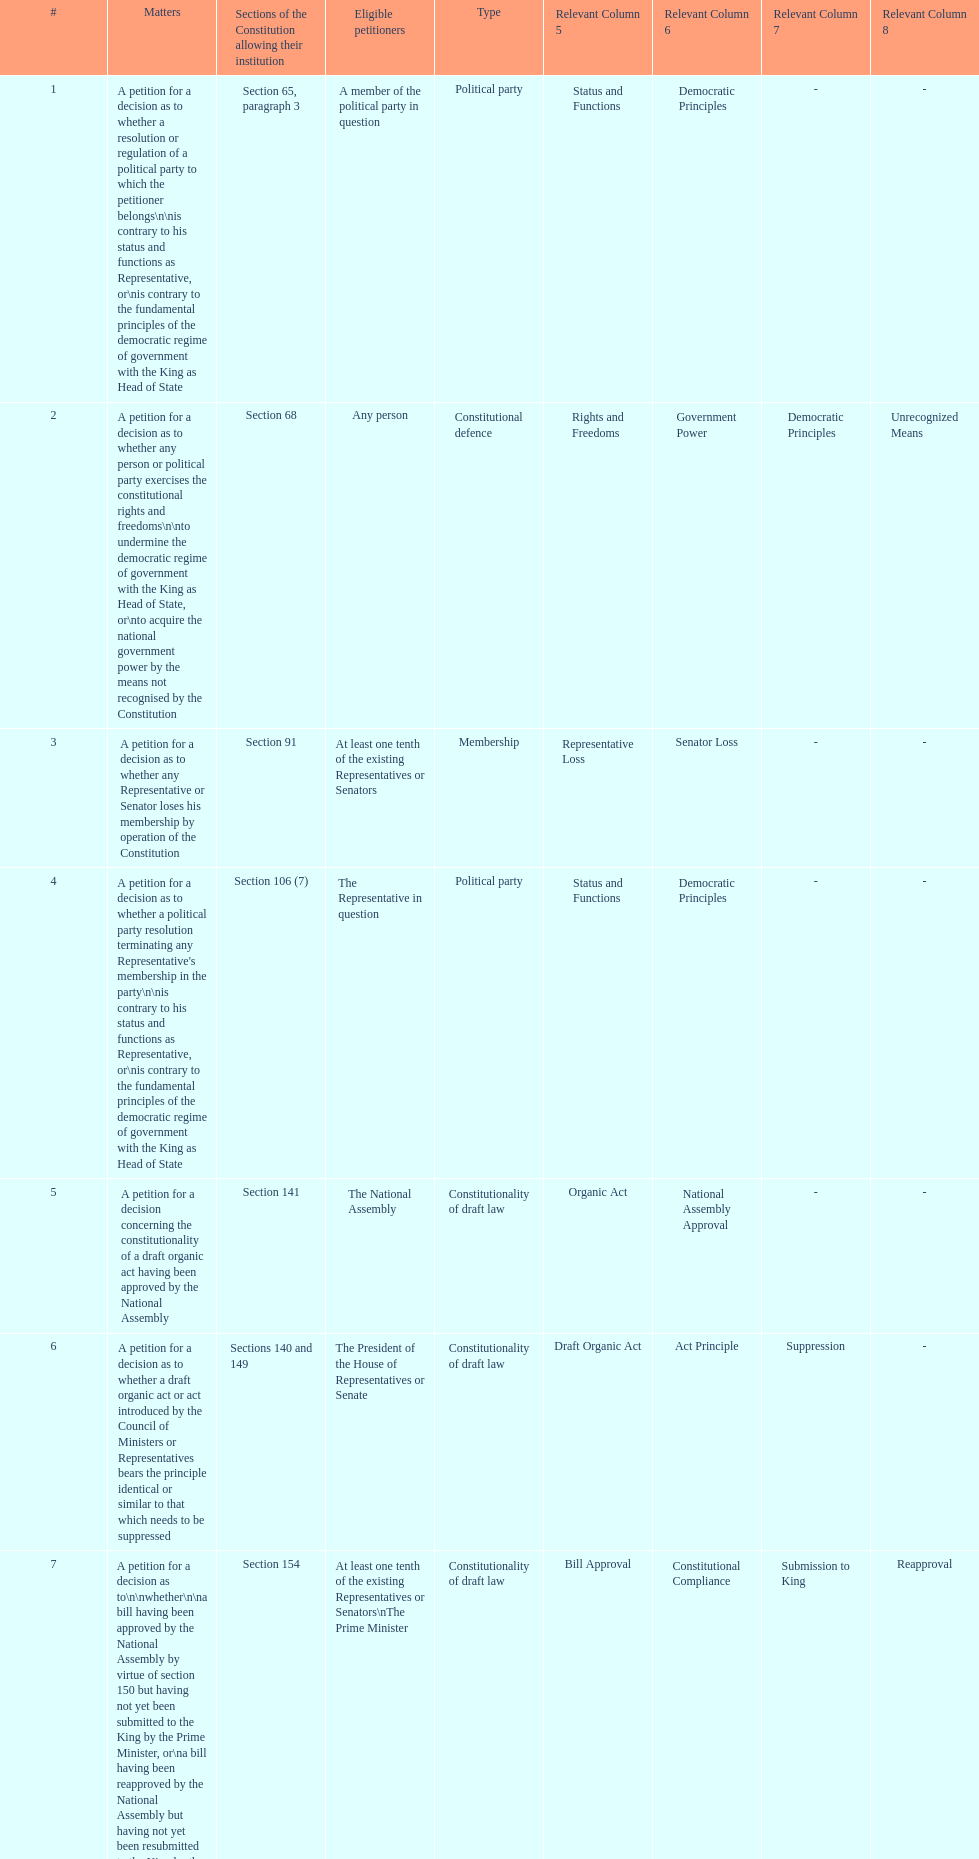How many matters have political party as their "type"? 3. 